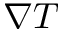Convert formula to latex. <formula><loc_0><loc_0><loc_500><loc_500>\nabla T</formula> 